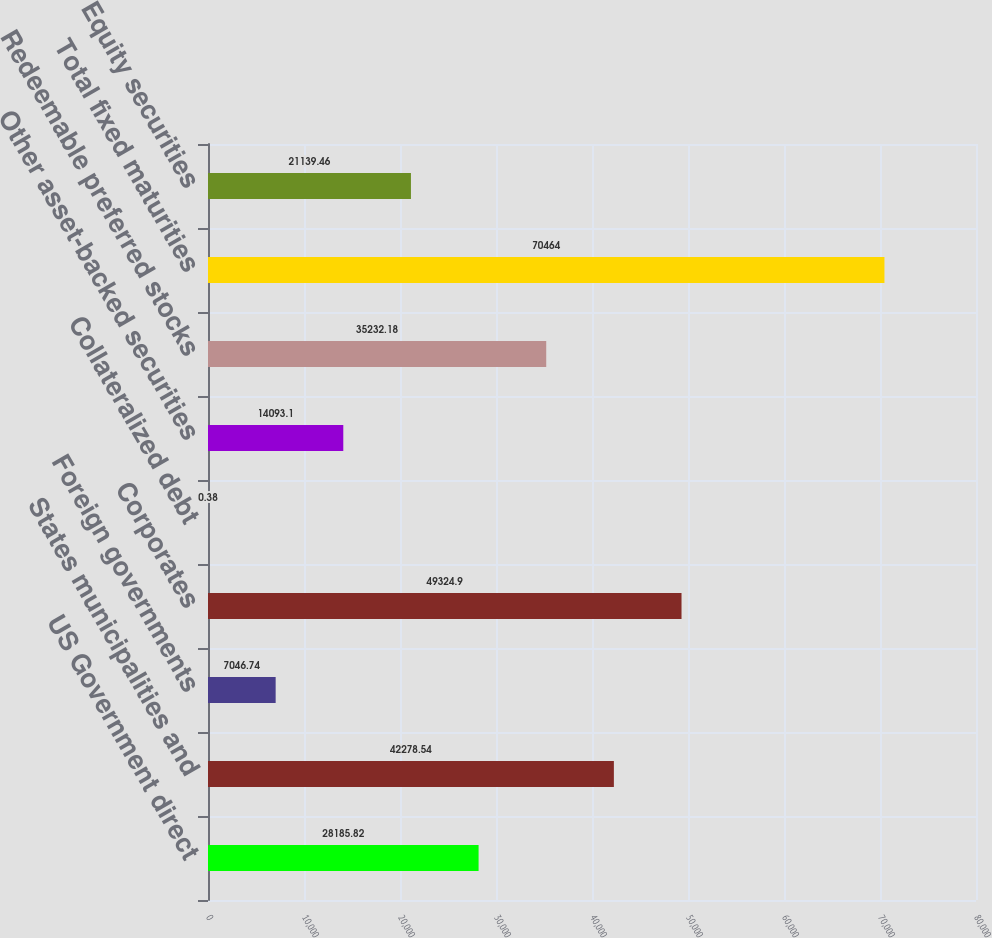<chart> <loc_0><loc_0><loc_500><loc_500><bar_chart><fcel>US Government direct<fcel>States municipalities and<fcel>Foreign governments<fcel>Corporates<fcel>Collateralized debt<fcel>Other asset-backed securities<fcel>Redeemable preferred stocks<fcel>Total fixed maturities<fcel>Equity securities<nl><fcel>28185.8<fcel>42278.5<fcel>7046.74<fcel>49324.9<fcel>0.38<fcel>14093.1<fcel>35232.2<fcel>70464<fcel>21139.5<nl></chart> 